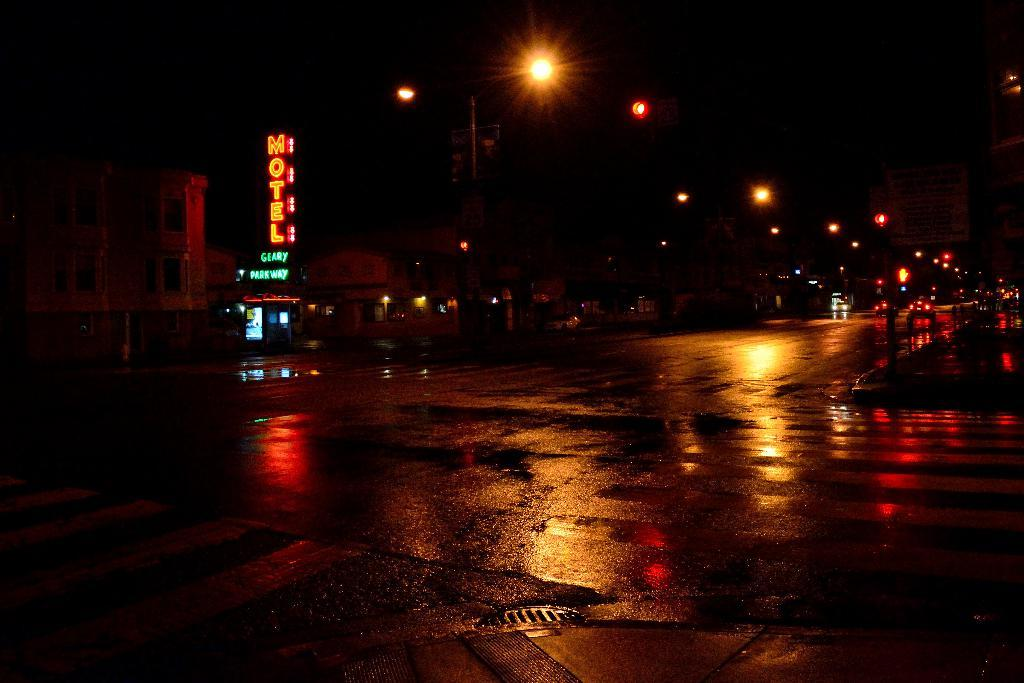What time of day is depicted in the image? The image was taken at night time. What type of structures can be seen in the image? There are buildings in the image. What is providing illumination in the image? Street lights are visible in the image. What mode of transportation can be seen in the image? There are vehicles on the road in the image. How would you describe the overall lighting in the image? The background of the image is dark. Can you see a family eating an apple with a blade in the image? There is no family, apple, or blade present in the image. 